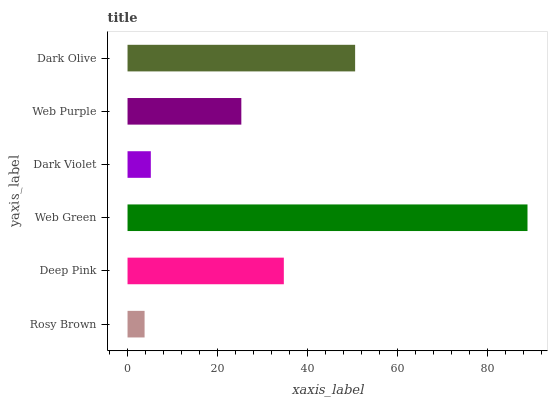Is Rosy Brown the minimum?
Answer yes or no. Yes. Is Web Green the maximum?
Answer yes or no. Yes. Is Deep Pink the minimum?
Answer yes or no. No. Is Deep Pink the maximum?
Answer yes or no. No. Is Deep Pink greater than Rosy Brown?
Answer yes or no. Yes. Is Rosy Brown less than Deep Pink?
Answer yes or no. Yes. Is Rosy Brown greater than Deep Pink?
Answer yes or no. No. Is Deep Pink less than Rosy Brown?
Answer yes or no. No. Is Deep Pink the high median?
Answer yes or no. Yes. Is Web Purple the low median?
Answer yes or no. Yes. Is Dark Olive the high median?
Answer yes or no. No. Is Rosy Brown the low median?
Answer yes or no. No. 